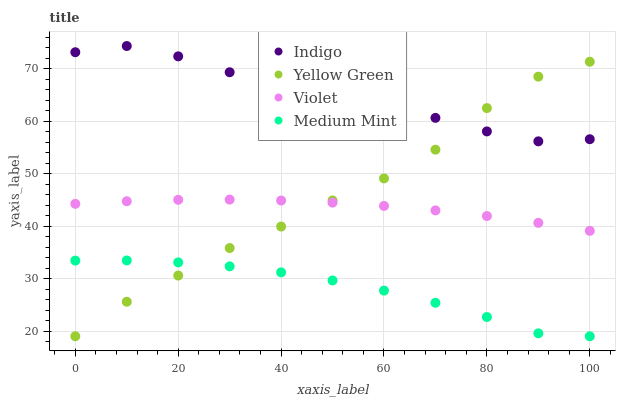Does Medium Mint have the minimum area under the curve?
Answer yes or no. Yes. Does Indigo have the maximum area under the curve?
Answer yes or no. Yes. Does Yellow Green have the minimum area under the curve?
Answer yes or no. No. Does Yellow Green have the maximum area under the curve?
Answer yes or no. No. Is Violet the smoothest?
Answer yes or no. Yes. Is Indigo the roughest?
Answer yes or no. Yes. Is Yellow Green the smoothest?
Answer yes or no. No. Is Yellow Green the roughest?
Answer yes or no. No. Does Medium Mint have the lowest value?
Answer yes or no. Yes. Does Indigo have the lowest value?
Answer yes or no. No. Does Indigo have the highest value?
Answer yes or no. Yes. Does Yellow Green have the highest value?
Answer yes or no. No. Is Medium Mint less than Indigo?
Answer yes or no. Yes. Is Indigo greater than Violet?
Answer yes or no. Yes. Does Yellow Green intersect Violet?
Answer yes or no. Yes. Is Yellow Green less than Violet?
Answer yes or no. No. Is Yellow Green greater than Violet?
Answer yes or no. No. Does Medium Mint intersect Indigo?
Answer yes or no. No. 